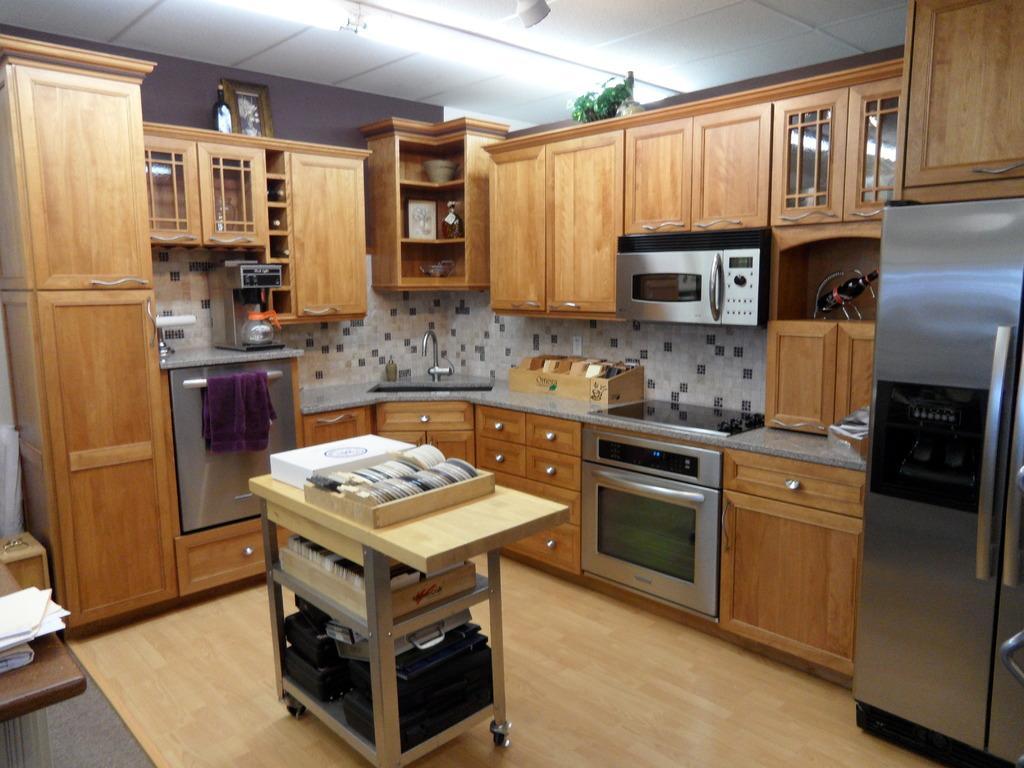In one or two sentences, can you explain what this image depicts? In this image we can see a table, trays, plates, boxes, oven, stove, towel, refrigerator, cupboards, wash basin, tap, bottles, kettle, plant, and frames. At the top of the image we can see ceiling. 